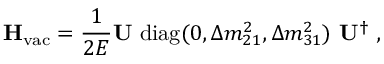<formula> <loc_0><loc_0><loc_500><loc_500>H _ { v a c } = \frac { 1 } { 2 E } U d i a g ( 0 , \Delta m _ { 2 1 } ^ { 2 } , \Delta m _ { 3 1 } ^ { 2 } ) U ^ { \dagger } \, ,</formula> 